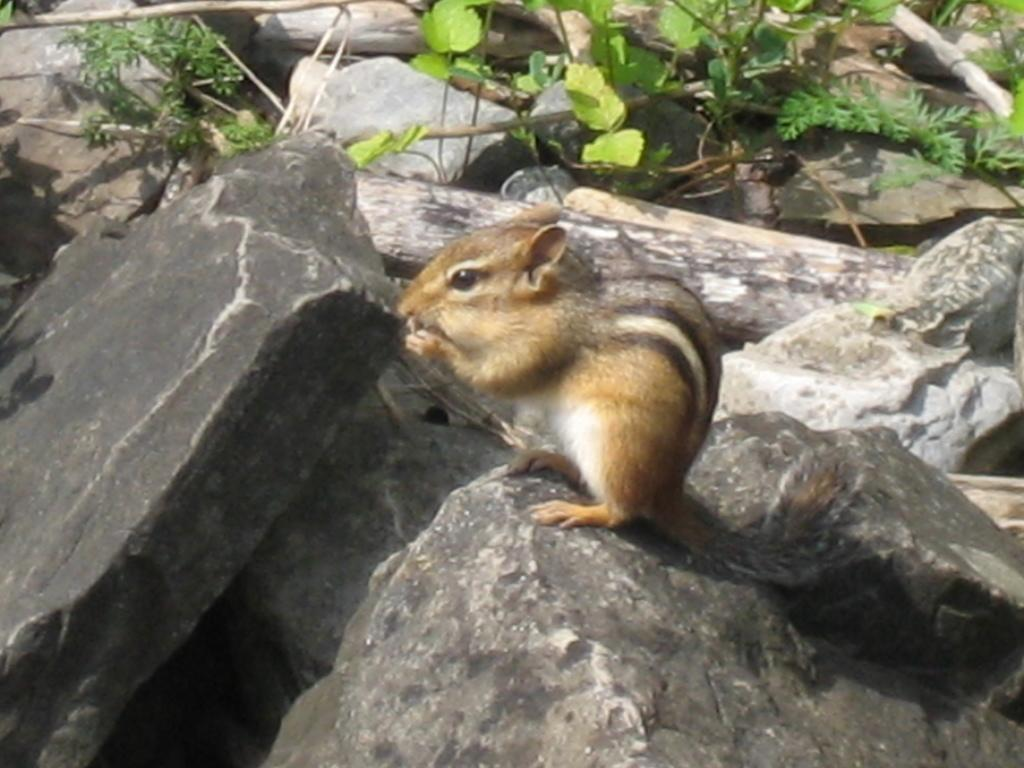What type of natural objects can be seen in the image? There are rocks and wooden trunks in the image. What is the squirrel doing in the image? The squirrel is on a rock in the image. What type of vegetation can be seen in the image? Few leaves are visible at the top of the image. How does the squirrel mark its territory in the image? There is no indication in the image that the squirrel is marking its territory. 